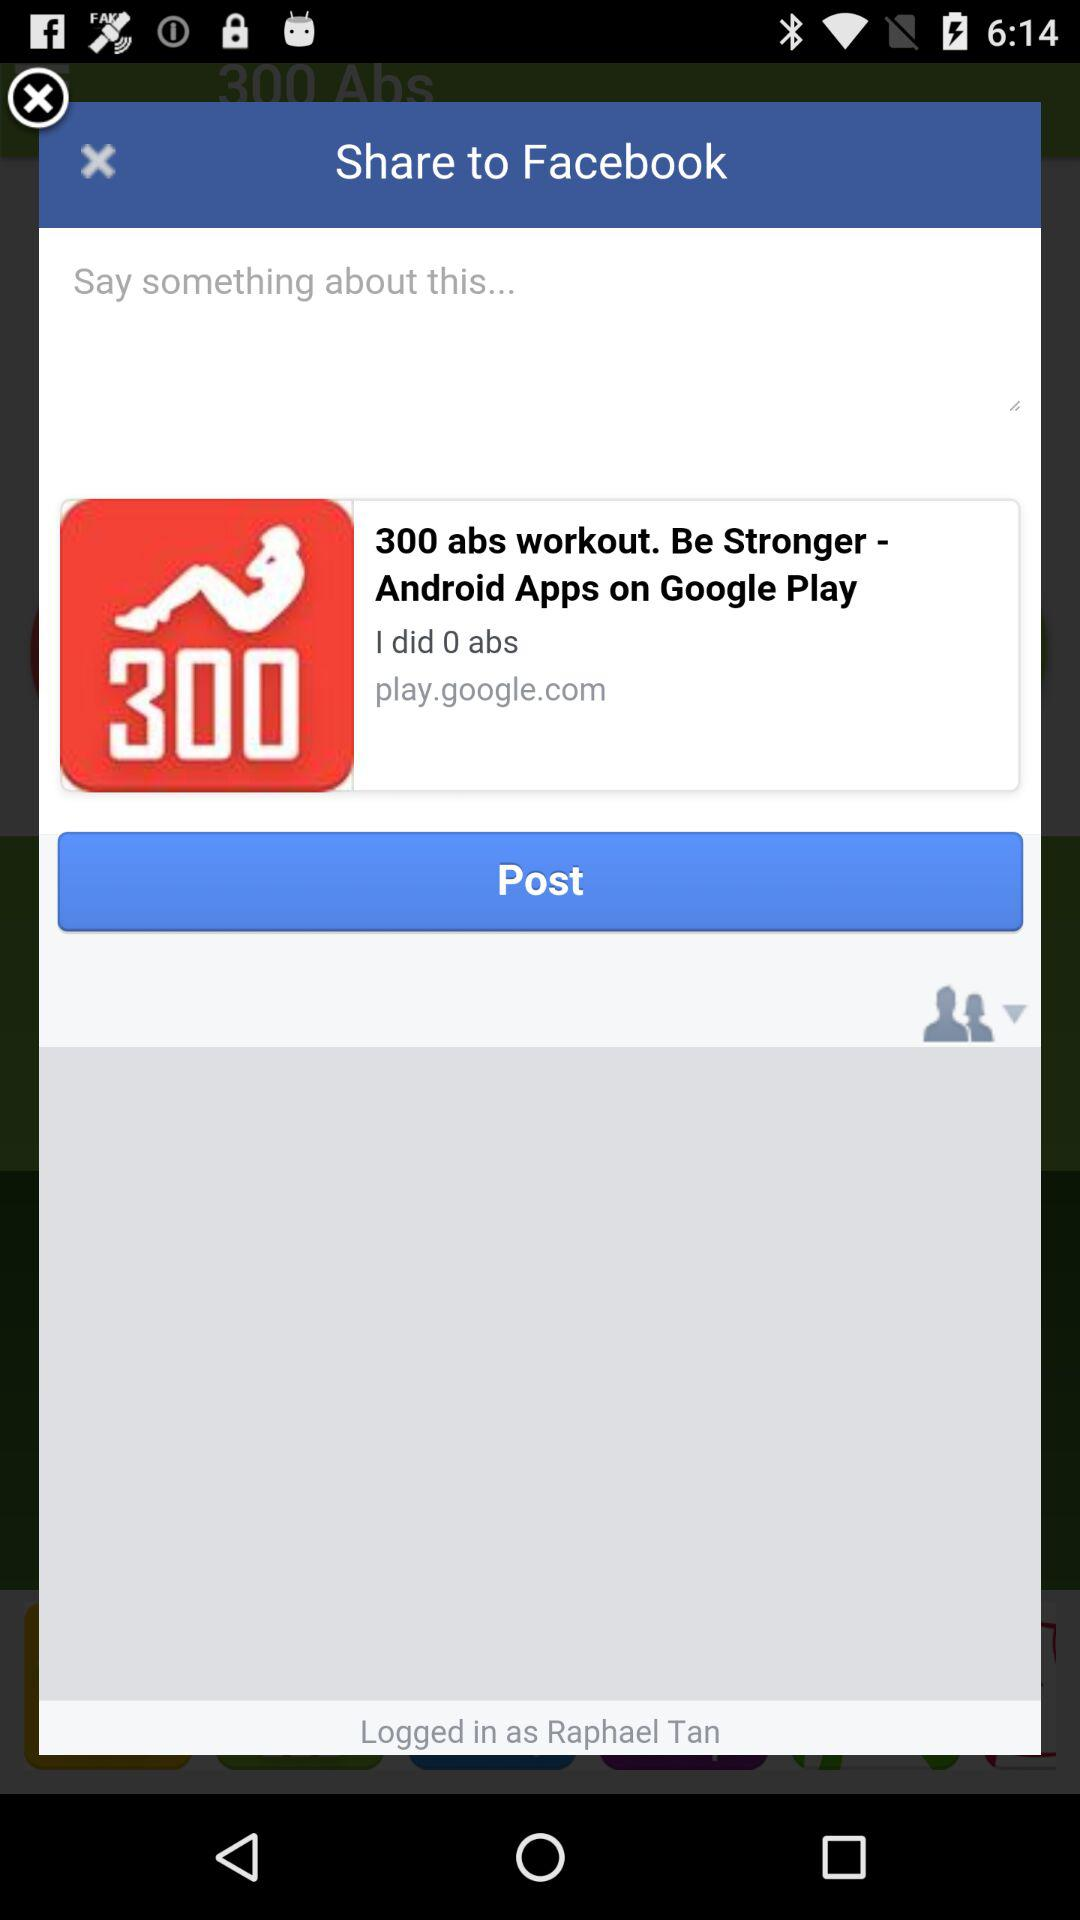What is the option to share? The option is "Facebook". 